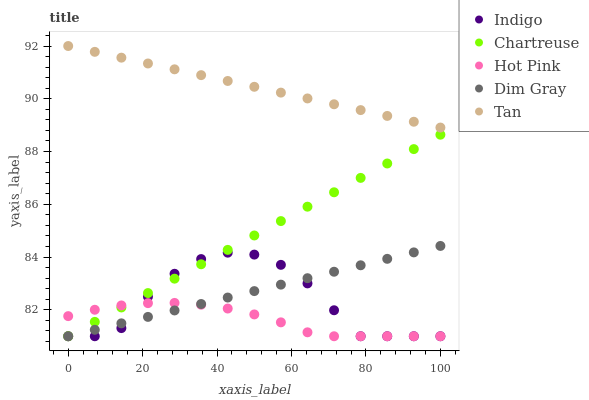Does Hot Pink have the minimum area under the curve?
Answer yes or no. Yes. Does Tan have the maximum area under the curve?
Answer yes or no. Yes. Does Indigo have the minimum area under the curve?
Answer yes or no. No. Does Indigo have the maximum area under the curve?
Answer yes or no. No. Is Tan the smoothest?
Answer yes or no. Yes. Is Indigo the roughest?
Answer yes or no. Yes. Is Hot Pink the smoothest?
Answer yes or no. No. Is Hot Pink the roughest?
Answer yes or no. No. Does Chartreuse have the lowest value?
Answer yes or no. Yes. Does Tan have the lowest value?
Answer yes or no. No. Does Tan have the highest value?
Answer yes or no. Yes. Does Indigo have the highest value?
Answer yes or no. No. Is Chartreuse less than Tan?
Answer yes or no. Yes. Is Tan greater than Indigo?
Answer yes or no. Yes. Does Indigo intersect Chartreuse?
Answer yes or no. Yes. Is Indigo less than Chartreuse?
Answer yes or no. No. Is Indigo greater than Chartreuse?
Answer yes or no. No. Does Chartreuse intersect Tan?
Answer yes or no. No. 